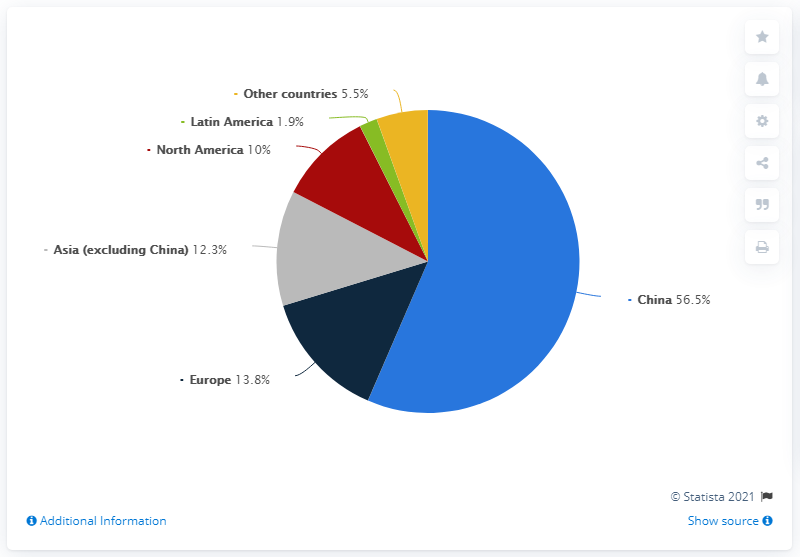Outline some significant characteristics in this image. According to data from 2019, China had the highest demand for primary aluminum among all regions. The sum of the segments excluding the largest one is 43.5. The combined distribution of North America, Latin America, and Other countries exceeds that of Europe by 3.6 times. 